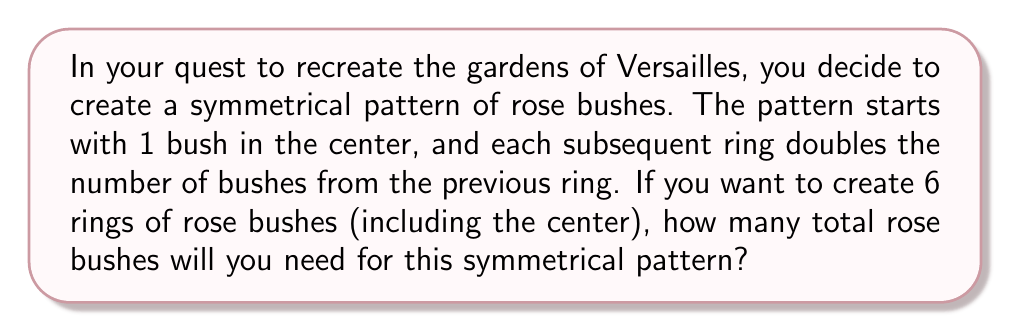Help me with this question. Let's approach this step-by-step:

1) First, let's identify the pattern:
   - Center (Ring 0): $2^0 = 1$ bush
   - Ring 1: $2^1 = 2$ bushes
   - Ring 2: $2^2 = 4$ bushes
   - Ring 3: $2^3 = 8$ bushes
   - Ring 4: $2^4 = 16$ bushes
   - Ring 5: $2^5 = 32$ bushes

2) We can see that for each ring n, the number of bushes is $2^n$.

3) To find the total number of bushes, we need to sum all these values from $n = 0$ to $n = 5$:

   $$\sum_{n=0}^5 2^n$$

4) This is a geometric series with first term $a = 1$ and common ratio $r = 2$.

5) The sum of a geometric series is given by the formula:
   
   $$S_n = \frac{a(1-r^{n+1})}{1-r}$$

   where $a$ is the first term, $r$ is the common ratio, and $n$ is the number of terms.

6) In our case, $a = 1$, $r = 2$, and $n = 6$ (because we have 6 rings, numbered 0 to 5):

   $$S_6 = \frac{1(1-2^{6+1})}{1-2} = \frac{1-2^7}{-1} = 2^7 - 1 = 128 - 1 = 127$$

Therefore, you will need 127 rose bushes to create this symmetrical pattern.
Answer: 127 rose bushes 